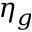Convert formula to latex. <formula><loc_0><loc_0><loc_500><loc_500>\eta _ { g }</formula> 